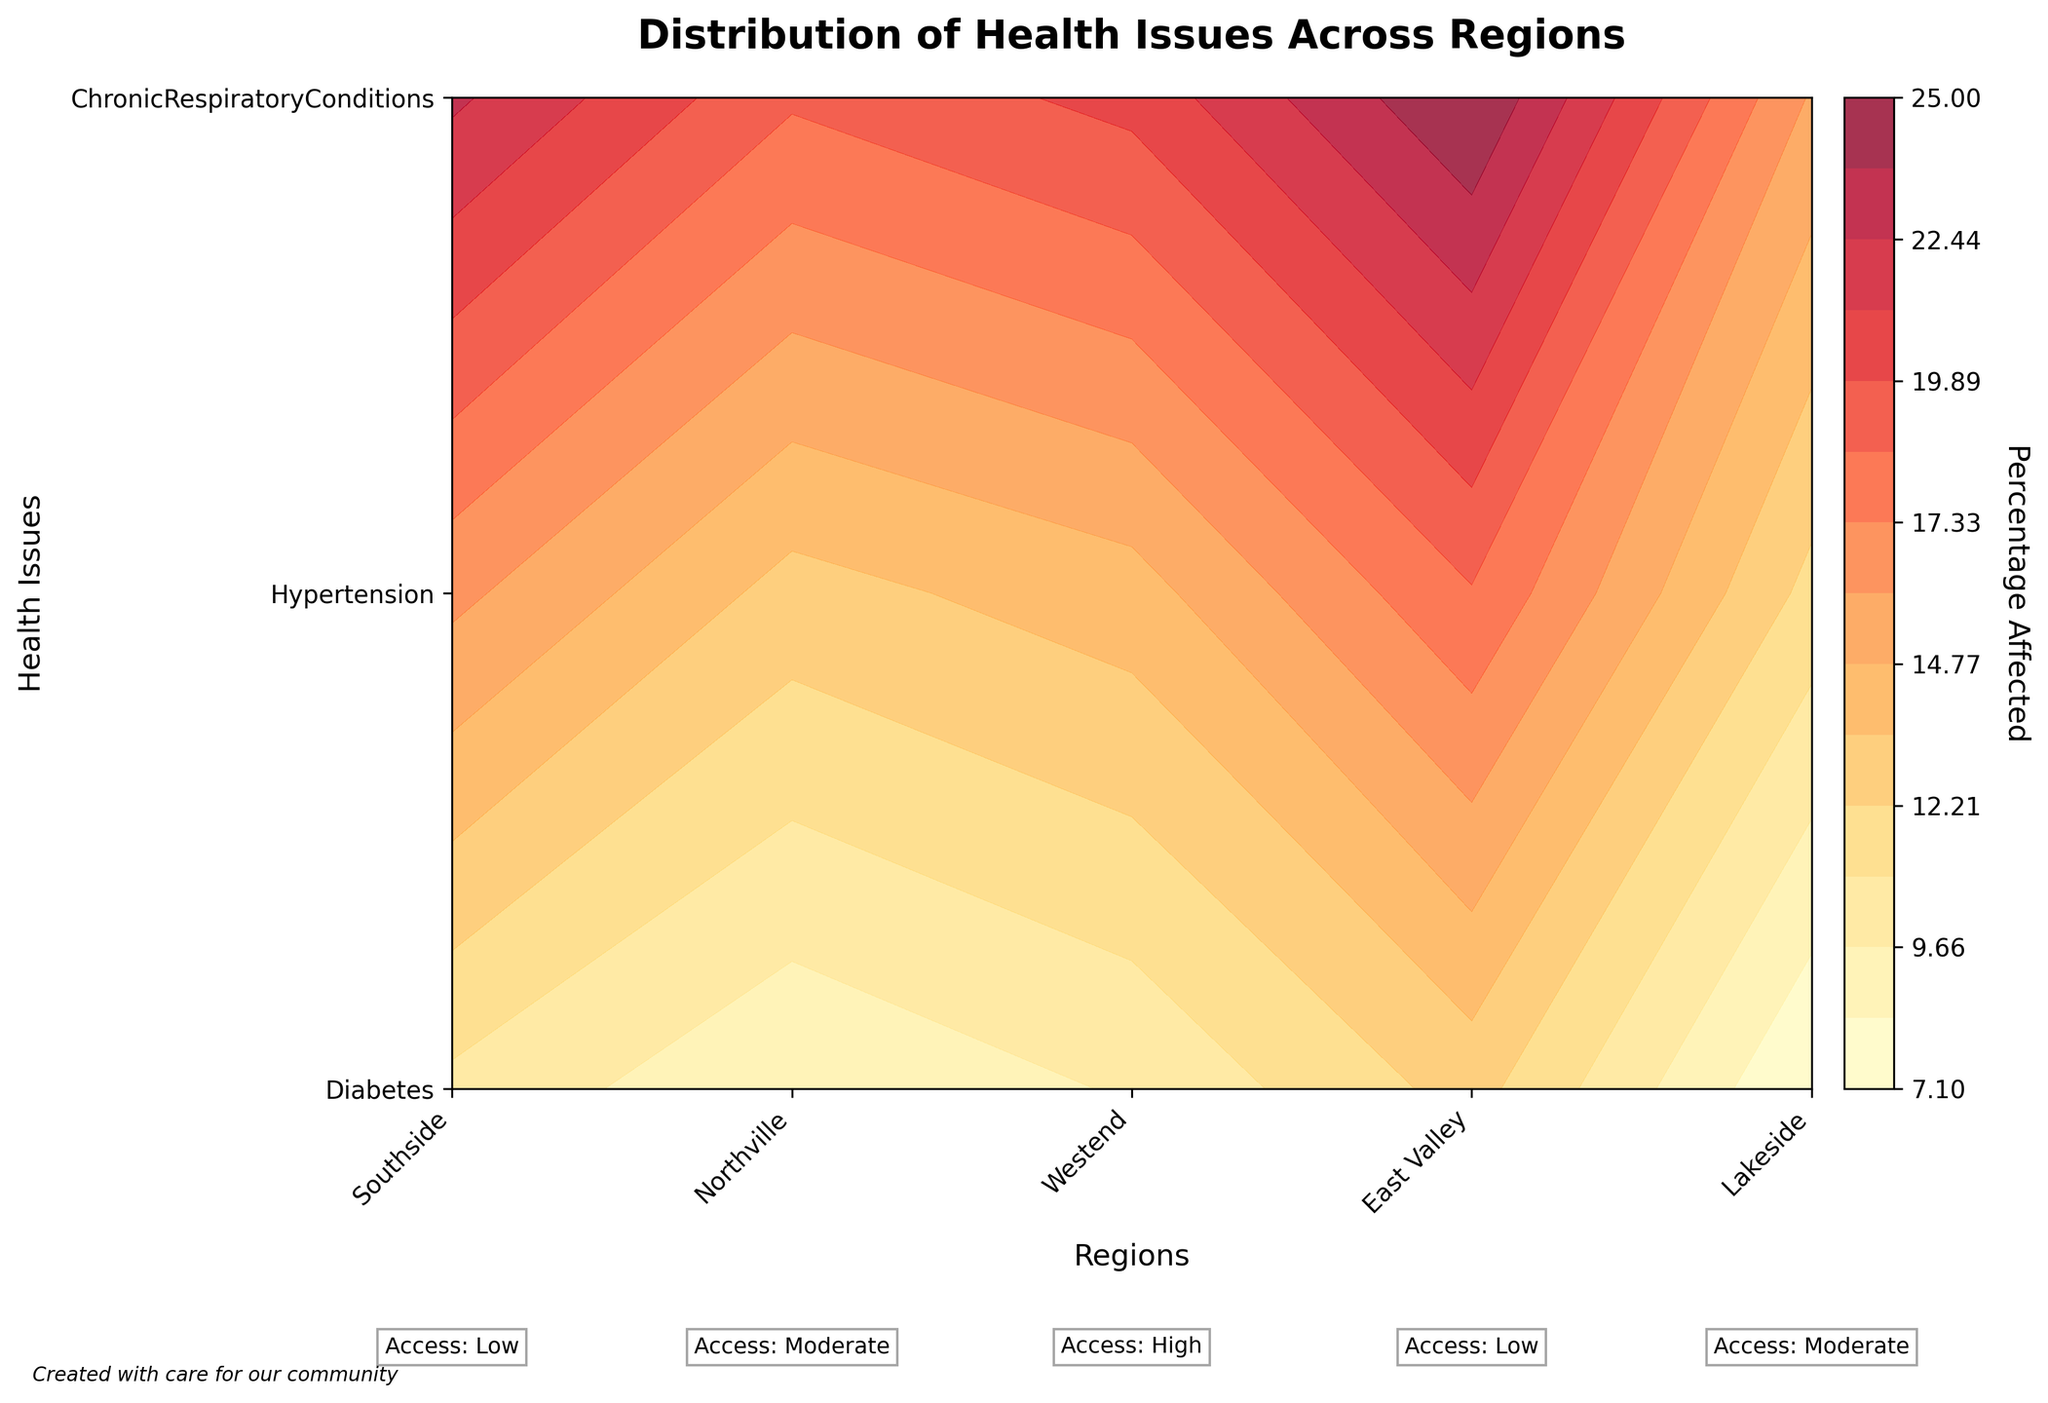Which region has the highest percentage of people affected by hypertension? Locate the contours for hypertension and compare the percentage values across the regions. The highest percentage is found in the Southside region.
Answer: Southside What is the range of percentages affected by chronic respiratory conditions across all regions? Find the contour levels for chronic respiratory conditions in each region. The lowest percentage is in the Westend (7.1%) and the highest is in Southside (12.7%), giving a range from 7.1% to 12.7%.
Answer: 7.1% to 12.7% How does the access to medical care annotation differ between Northville and East Valley? Look at the text annotations just below the x-axis labels for Northville and East Valley. Northville has "Moderate" access to medical care, while East Valley has "Low" access.
Answer: Moderate vs Low Which health issue shows percentage levels spanning the widest range across different regions? Compare the range of percentage levels for each health issue using the contour colors. Hypertension spans from 15.9% to 25%. Diabetes and chronic respiratory conditions have narrower ranges.
Answer: Hypertension What percentage of people in Lakeside are affected by diabetes? Look at the contour levels for diabetes in the Lakeside region. The percentage affected is around 13%.
Answer: 13% Which region has the lowest percentage affected by any health issue? Compare the contour levels for all health issues across regions to find the minimum value. The lowest percentage is in the Westend for chronic respiratory conditions (7.1%).
Answer: Westend for chronic respiratory conditions How do the percentages of people affected by diabetes in the Southside and Westend compare? Observe the contour levels for diabetes in Southside and Westend. In Southside, the percentage is 18.5%, while in Westend it is 11.8%.
Answer: Southside: 18.5%, Westend: 11.8% Does Northville have better access to medical care than Southside? Check the text annotations under the x-axis labels for Northville and Southside. Northville has "Moderate" access to medical care, whereas Southside has "Low" access.
Answer: Yes What pattern can be observed regarding access to medical care and the percentage affected by health issues? Observe the annotations for access to medical care and compare them with the contour levels. Regions with "Low" access generally have higher percentages affected by health issues, whereas regions with "High" access have lower percentages.
Answer: Low access correlates with higher percentages What is the percentage range of people affected by hypertension in regions with 'Low' access to medical care? Look at the regions with "Low" access (Southside, East Valley) and check the contour levels for hypertension. The range is from 22.7% (East Valley) to 25.0% (Southside).
Answer: 22.7% to 25.0% 